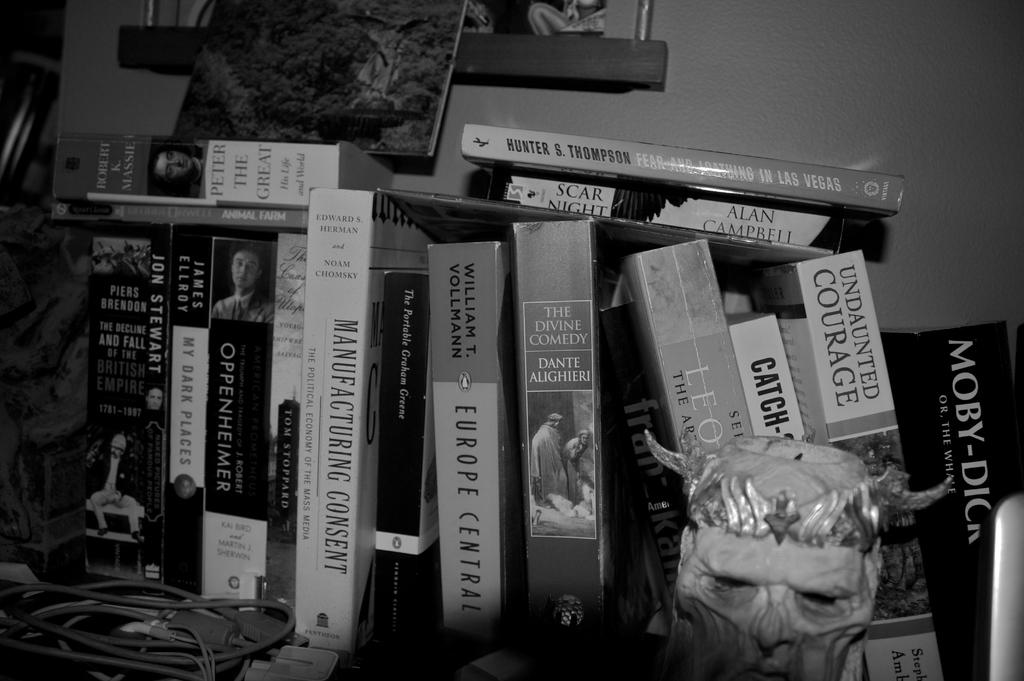<image>
Create a compact narrative representing the image presented. A stack of books are on a messy shelf including one titled Undaunted Courage. 